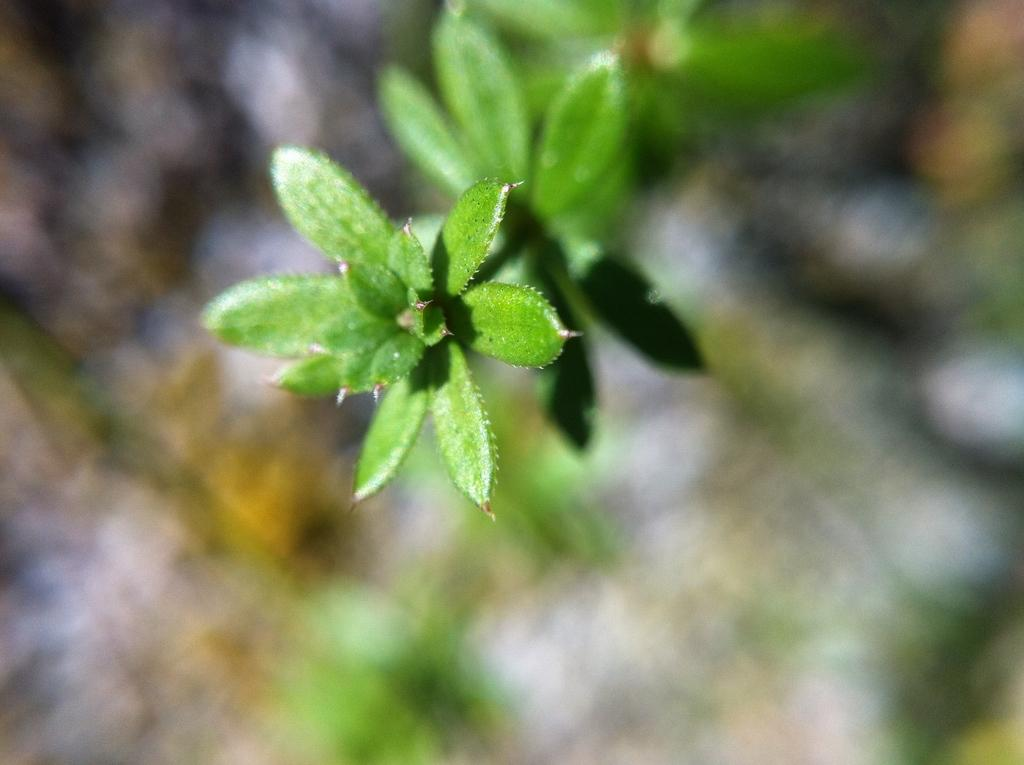What is present in the image? There is a plant in the image. What color is the plant? The plant is green in color. Can you describe the background of the image? The background of the image is blurry. What type of news can be heard coming from the field in the image? There is no field or any news present in the image, so it's not possible to determine what, if any, news might be heard. 